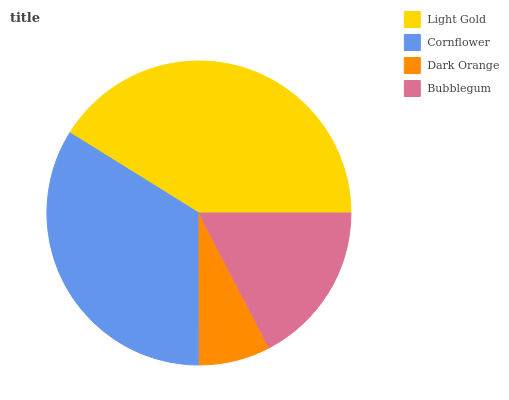Is Dark Orange the minimum?
Answer yes or no. Yes. Is Light Gold the maximum?
Answer yes or no. Yes. Is Cornflower the minimum?
Answer yes or no. No. Is Cornflower the maximum?
Answer yes or no. No. Is Light Gold greater than Cornflower?
Answer yes or no. Yes. Is Cornflower less than Light Gold?
Answer yes or no. Yes. Is Cornflower greater than Light Gold?
Answer yes or no. No. Is Light Gold less than Cornflower?
Answer yes or no. No. Is Cornflower the high median?
Answer yes or no. Yes. Is Bubblegum the low median?
Answer yes or no. Yes. Is Dark Orange the high median?
Answer yes or no. No. Is Dark Orange the low median?
Answer yes or no. No. 